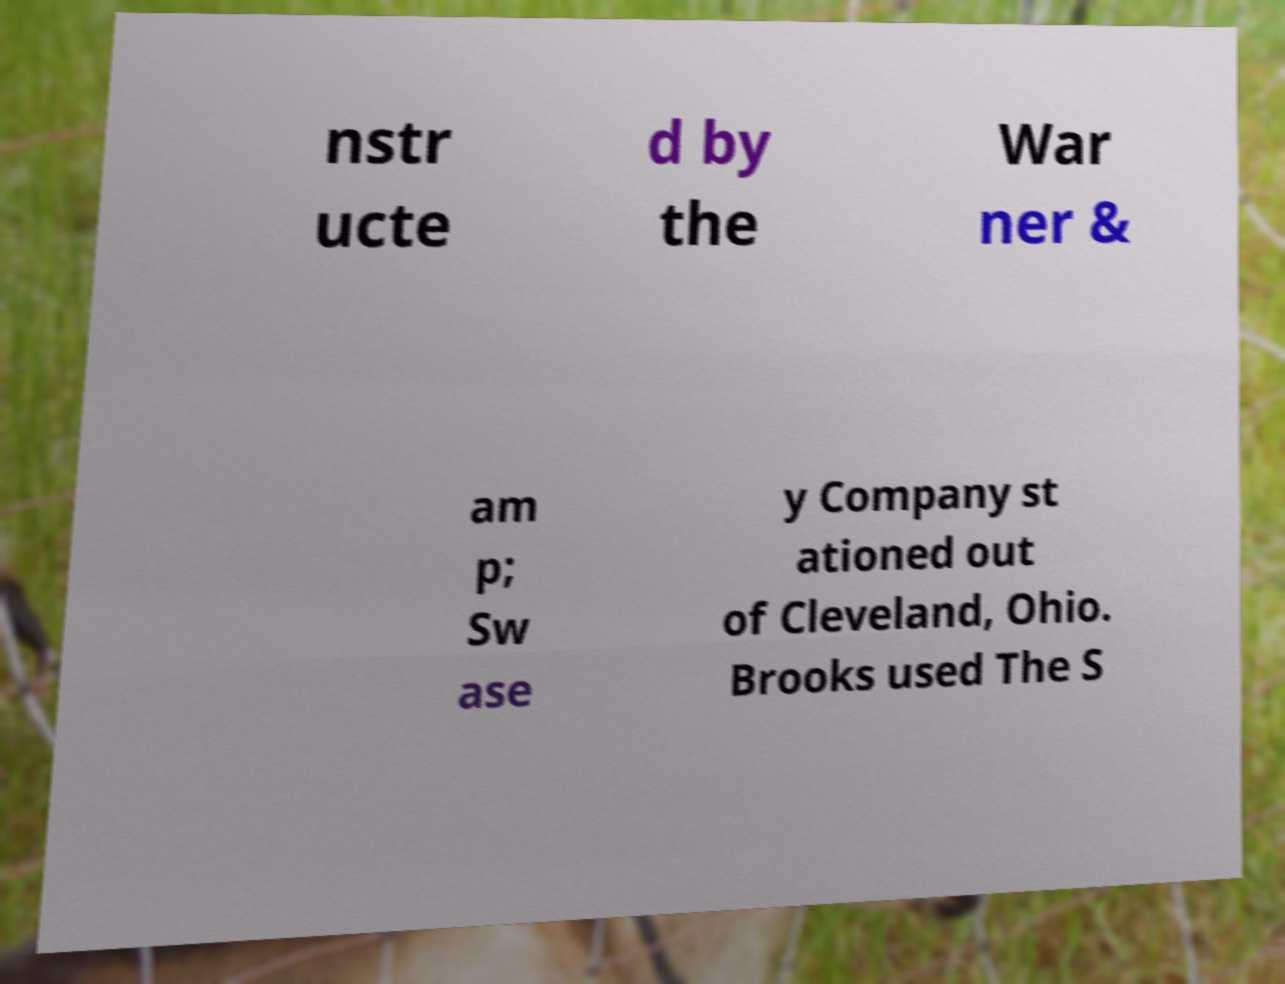Could you assist in decoding the text presented in this image and type it out clearly? nstr ucte d by the War ner & am p; Sw ase y Company st ationed out of Cleveland, Ohio. Brooks used The S 